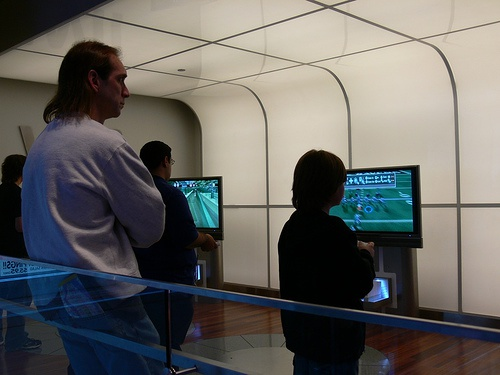Describe the objects in this image and their specific colors. I can see people in black, navy, gray, and blue tones, people in black, darkgray, gray, and lightgray tones, people in black, navy, gray, and blue tones, tv in black, teal, and lightblue tones, and people in black, navy, maroon, and gray tones in this image. 